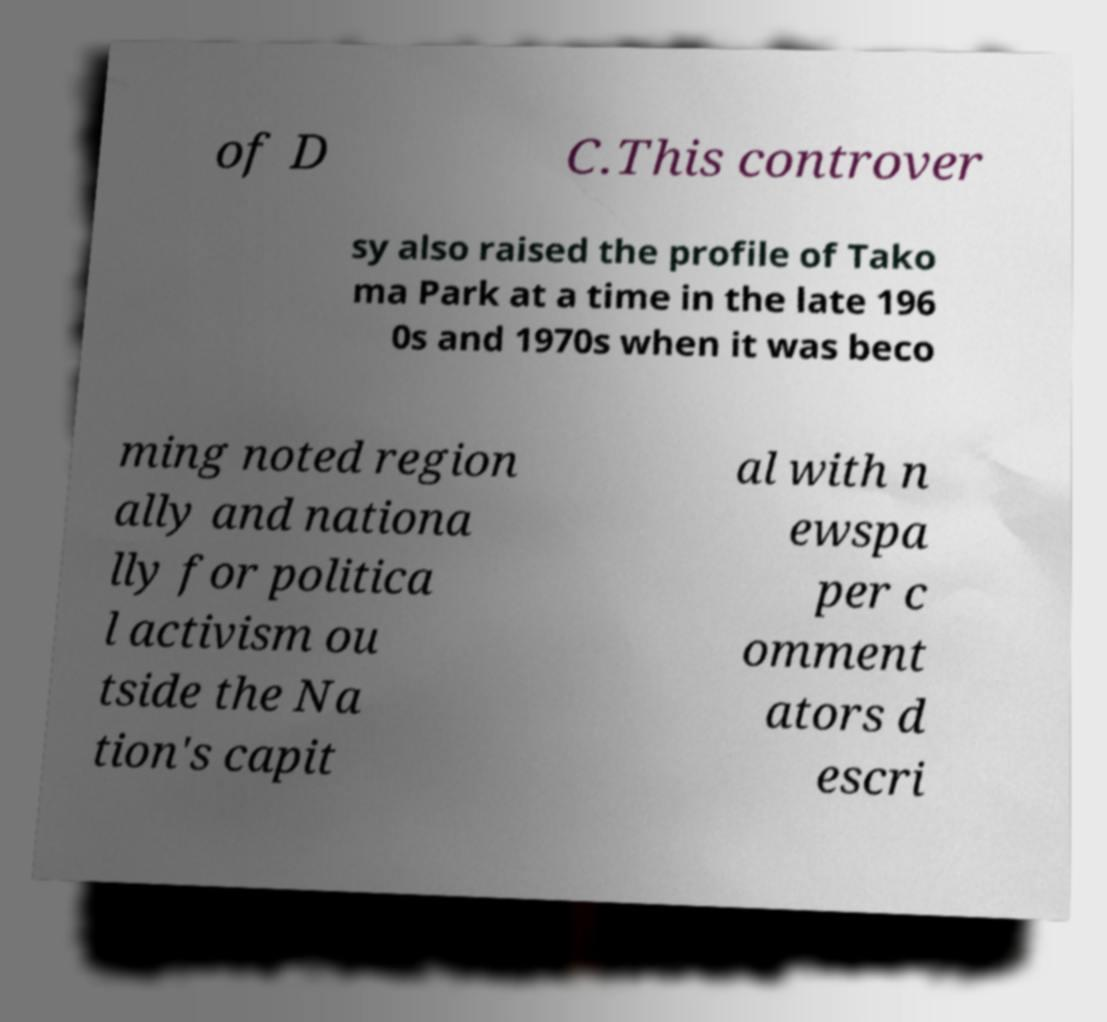Please identify and transcribe the text found in this image. of D C.This controver sy also raised the profile of Tako ma Park at a time in the late 196 0s and 1970s when it was beco ming noted region ally and nationa lly for politica l activism ou tside the Na tion's capit al with n ewspa per c omment ators d escri 